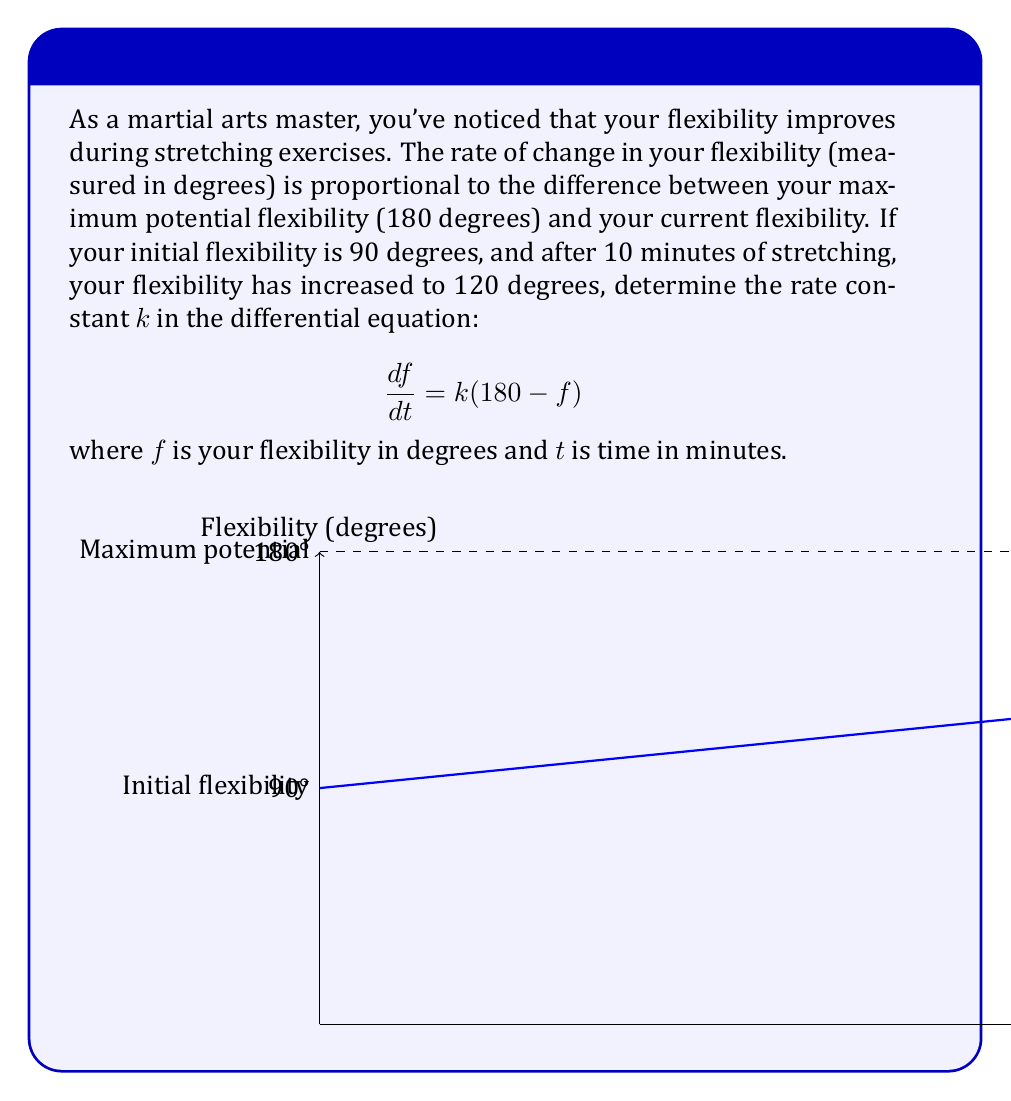Provide a solution to this math problem. Let's solve this step-by-step:

1) The given differential equation is:
   $$\frac{df}{dt} = k(180 - f)$$

2) This is a separable first-order differential equation. We can solve it as follows:
   $$\frac{df}{180 - f} = k dt$$

3) Integrating both sides:
   $$-\ln|180 - f| = kt + C$$

4) Solving for f:
   $$f = 180 - Ae^{-kt}$$
   where A is a constant of integration.

5) We know the initial condition: when t = 0, f = 90. Let's use this:
   $$90 = 180 - Ae^{0}$$
   $$A = 90$$

6) So our specific solution is:
   $$f = 180 - 90e^{-kt}$$

7) Now, we're told that after 10 minutes, f = 120. Let's use this:
   $$120 = 180 - 90e^{-10k}$$

8) Solving for k:
   $$90e^{-10k} = 60$$
   $$e^{-10k} = \frac{2}{3}$$
   $$-10k = \ln(\frac{2}{3})$$
   $$k = -\frac{1}{10}\ln(\frac{2}{3}) \approx 0.0405$$
Answer: $k \approx 0.0405$ min^(-1) 